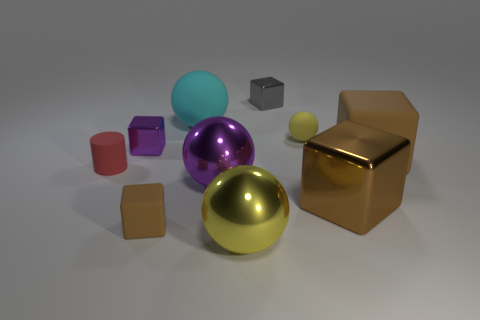Are there fewer purple shiny objects that are behind the big cyan matte object than big brown rubber things that are behind the tiny matte sphere?
Your answer should be compact. No. How many other things are the same color as the tiny sphere?
Your answer should be very brief. 1. Do the big rubber ball and the tiny matte cube have the same color?
Keep it short and to the point. No. How many tiny blocks are both behind the brown metallic cube and left of the small gray metal thing?
Provide a succinct answer. 1. Is the material of the small brown object the same as the cylinder?
Provide a succinct answer. Yes. There is a tiny block that is both in front of the gray shiny cube and behind the tiny brown matte block; what is its material?
Your response must be concise. Metal. The gray thing that is the same size as the red object is what shape?
Provide a short and direct response. Cube. How many things are brown shiny cubes that are behind the tiny brown block or tiny yellow matte cubes?
Provide a succinct answer. 1. There is a red thing that is the same size as the purple shiny block; what is its material?
Your response must be concise. Rubber. There is a yellow sphere that is in front of the brown rubber block on the right side of the big object behind the purple metal block; what is its material?
Your answer should be compact. Metal. 